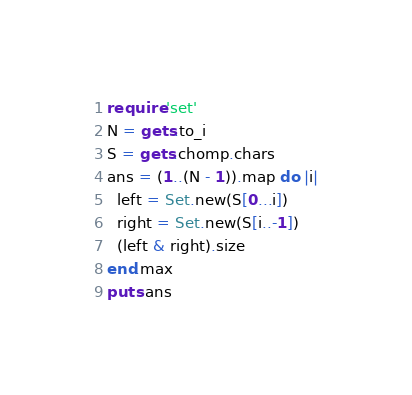Convert code to text. <code><loc_0><loc_0><loc_500><loc_500><_Ruby_>require 'set'
N = gets.to_i
S = gets.chomp.chars
ans = (1..(N - 1)).map do |i|
  left = Set.new(S[0...i])
  right = Set.new(S[i..-1])
  (left & right).size
end.max
puts ans
</code> 